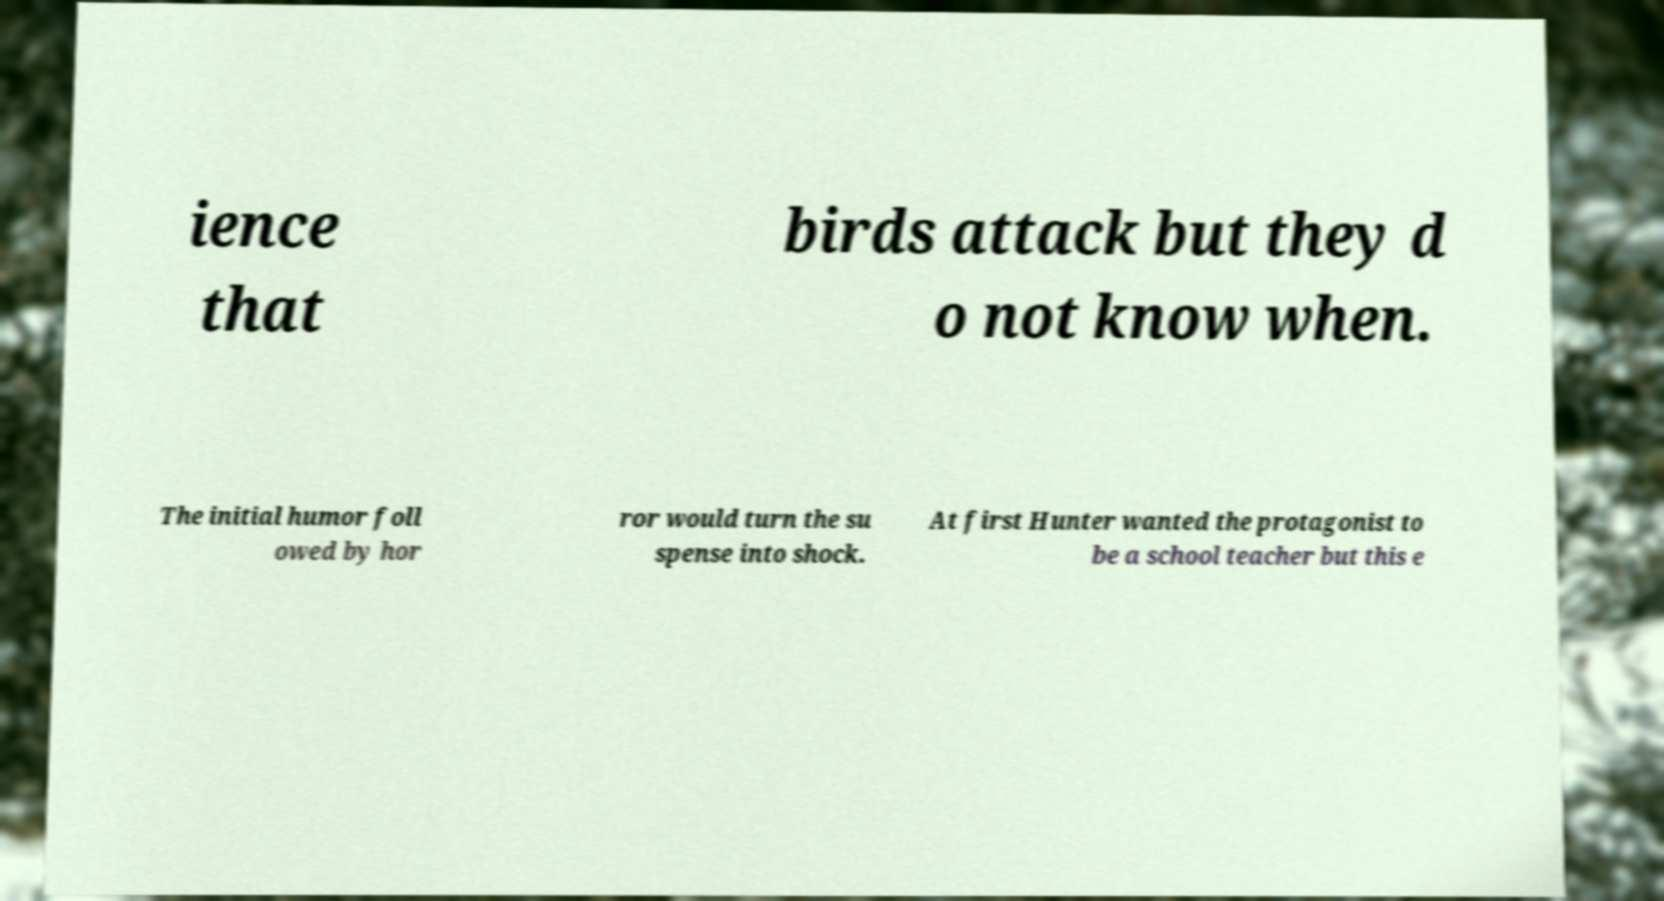What messages or text are displayed in this image? I need them in a readable, typed format. ience that birds attack but they d o not know when. The initial humor foll owed by hor ror would turn the su spense into shock. At first Hunter wanted the protagonist to be a school teacher but this e 